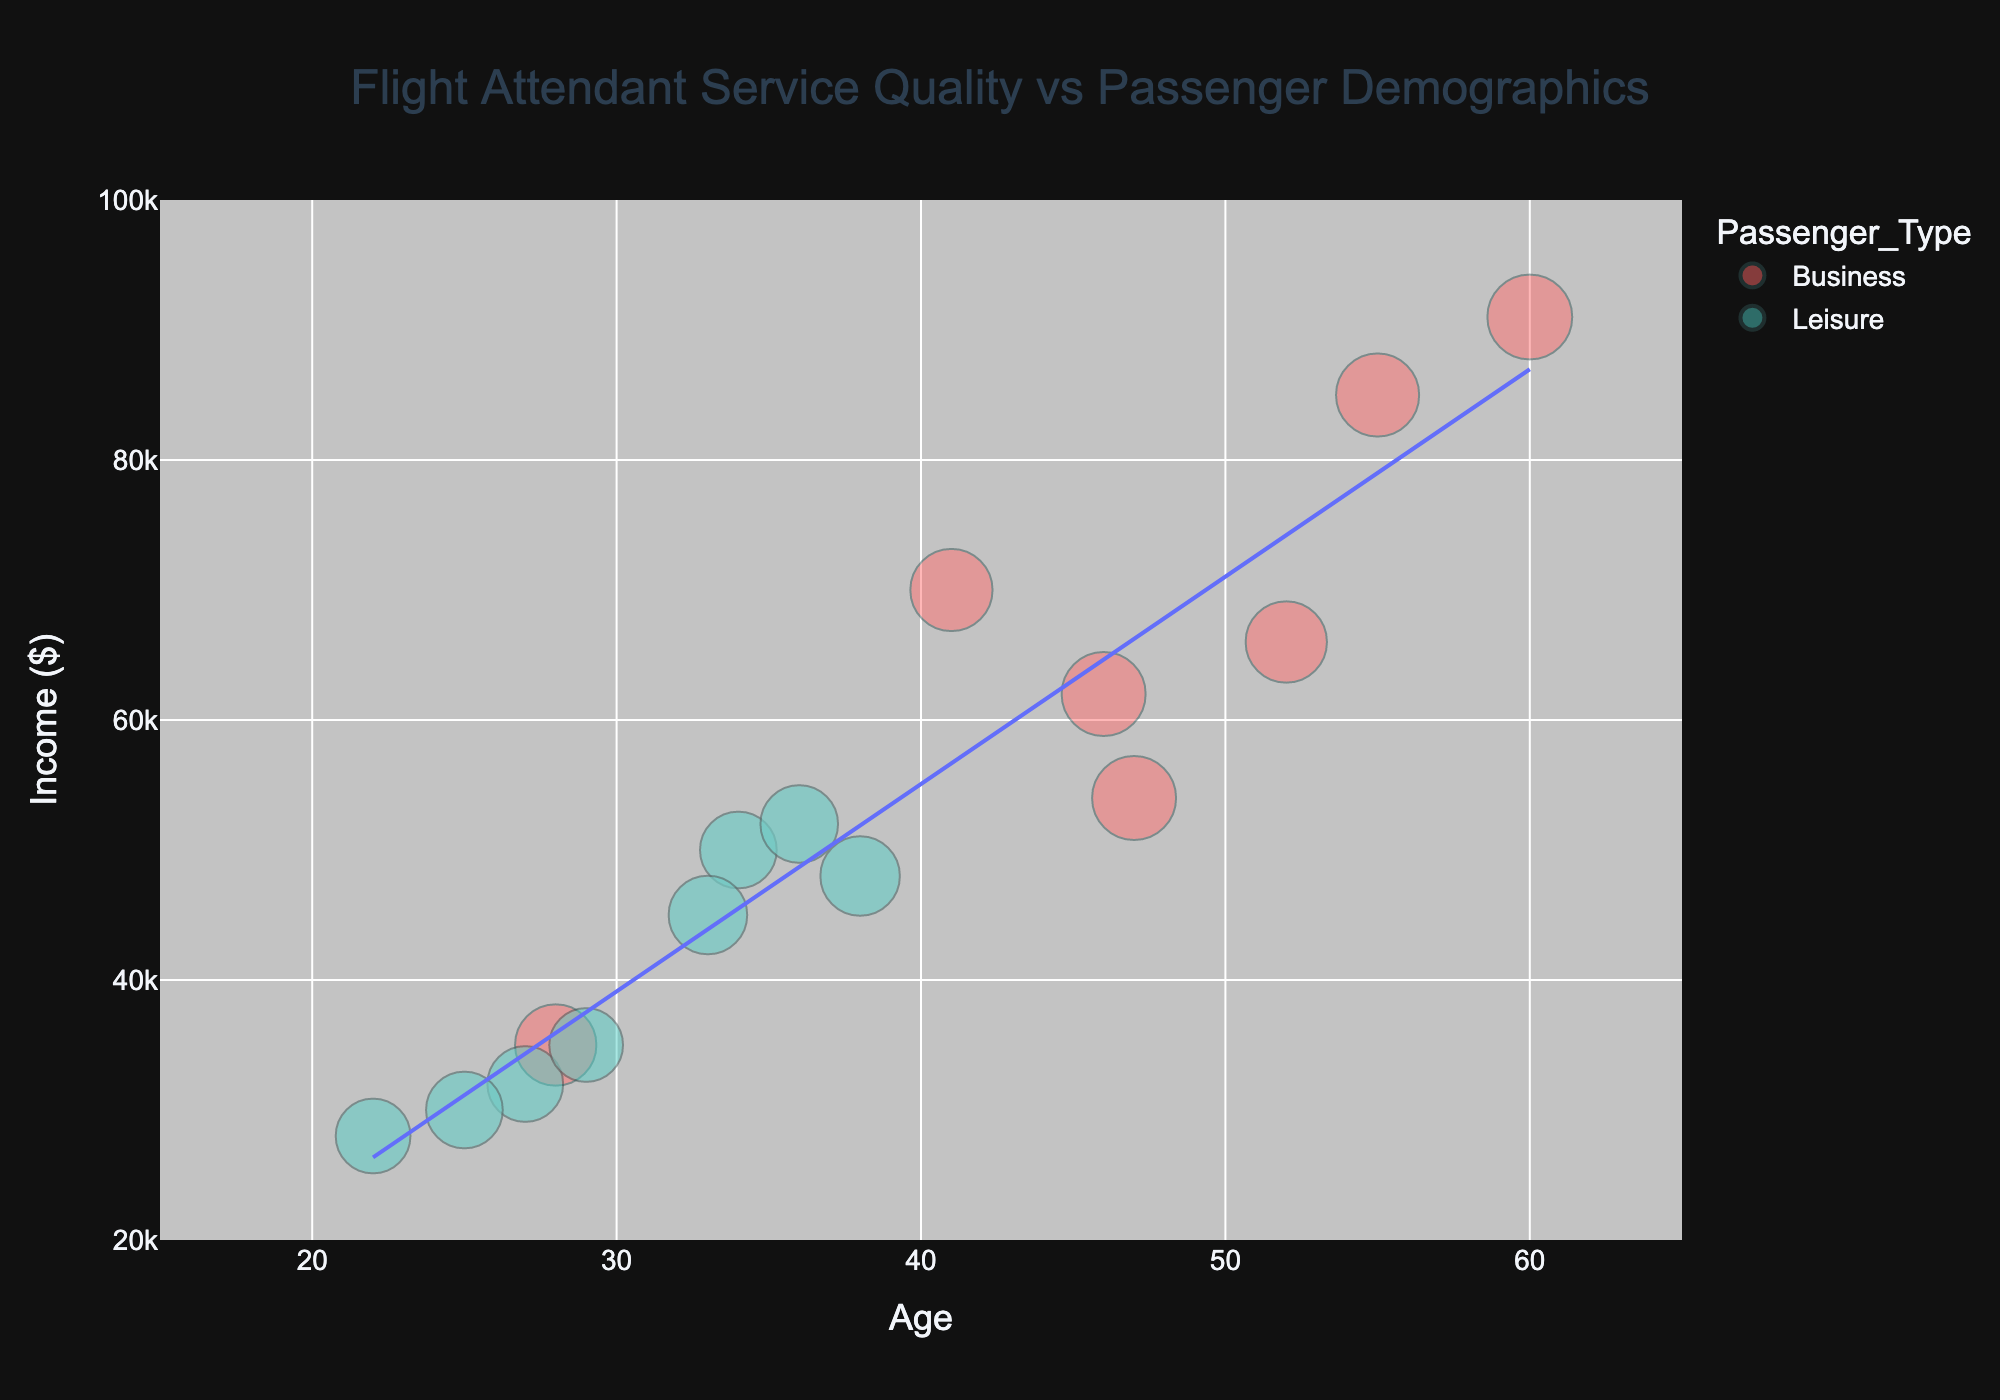What is the title of the figure? The title of the figure is located at the top and is formatted in a larger font size and different color to stand out. It reads "Flight Attendant Service Quality vs Passenger Demographics."
Answer: Flight Attendant Service Quality vs Passenger Demographics How many colored categories represent passenger types in the figure? The figure uses color to differentiate between passenger types, seen in the bubbles. There are two distinct colors, which means there are two categories: Business and Leisure.
Answer: 2 What are the maximum and minimum ages shown on the x-axis? The x-axis is labeled "Age" and displays data points between the age ranges. The maximum age is 60, and the minimum age is 22.
Answer: 22, 60 Which passenger type has the highest service quality rating, and what is that rating? The service quality rating is represented by the size of the bubbles. The largest bubble represents the highest rating, located in the Business category. The highest rating is 4.9.
Answer: Business, 4.9 Is there a trend line in the figure, and what is its general direction? The figure includes a trend line that runs through the data points. It is added to show the general direction of the data. The trend line slopes upward, indicating a positive correlation between passenger age and income.
Answer: Upward What is the passenger income for a 34-year-old leisure passenger? Locate the bubble that corresponds to the leisure passenger type at an age of 34. The y-axis value for this point, "Income ($)," is 50,000.
Answer: $50,000 What is the average service quality rating for business passengers? Identify all bubbles labeled as the Business category, read off their service ratings, sum them, and divide by the number of ratings. (4.5 + 4.8 + 4.7 + 4.6 + 4.5 + 4.9 + 4.8) / 7 = 4.69.
Answer: 4.69 Which passenger type has the higher income, Business or Leisure, on average? Compare the income values for each bubble by passenger type (Business and Leisure). Calculate the average income for each type and compare. Business has higher average income.
Answer: Business What is the service rating difference between the oldest and youngest business passengers? Find the service ratings for the oldest (age 60, rating 4.9) and youngest (age 28, rating 4.5) business passengers. Compute the difference: 4.9 - 4.5 = 0.4.
Answer: 0.4 Which age group (in decades) appears to have more leisure passengers based on the figure? Group the leisure passengers by their ages in decades (20s, 30s, 40s, etc.) and count their occurrences. The 20s (22, 27, 25, 29) have more leisure passengers.
Answer: 20s 